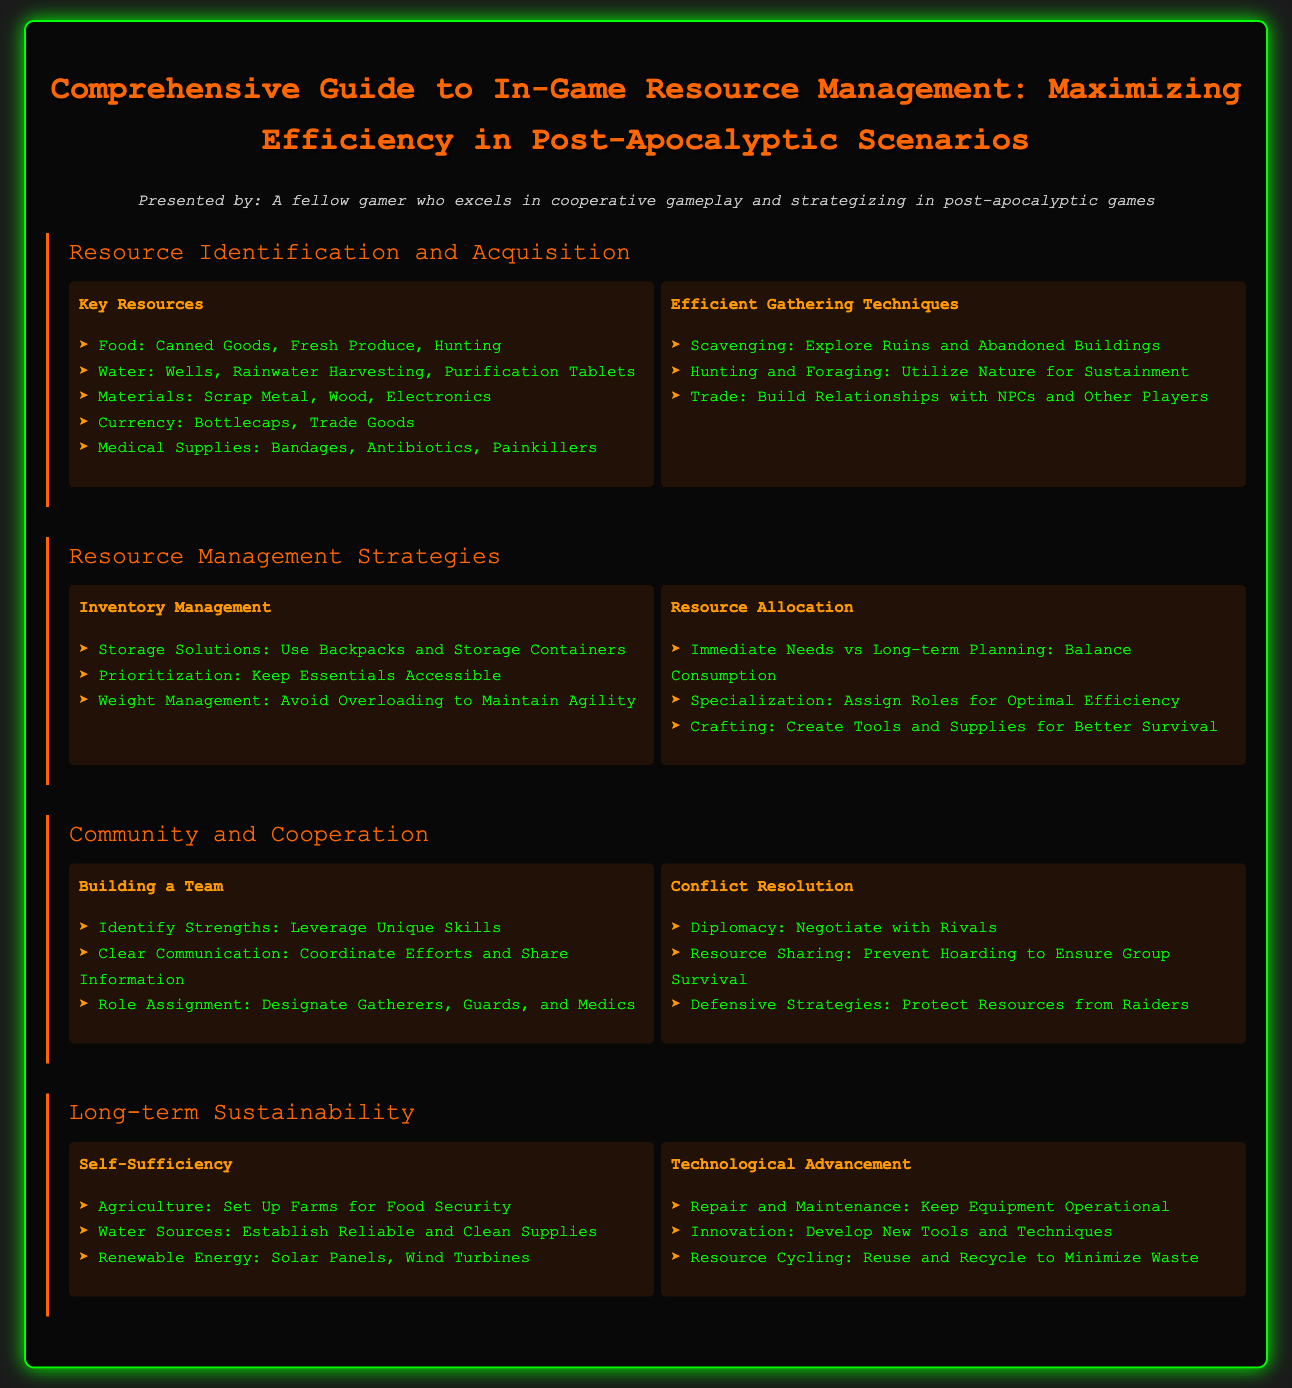what are the key medical supplies listed? The document lists medical supplies that include Bandages, Antibiotics, and Painkillers as key items.
Answer: Bandages, Antibiotics, Painkillers what are three efficient gathering techniques mentioned? The document specifies three techniques: Scavenging, Hunting and Foraging, and Trade as efficient gathering methods.
Answer: Scavenging, Hunting and Foraging, Trade what is a strategy for inventory management? The document suggests using Storage Solutions, keeping Essentials Accessible, and avoiding Overloading as strategies for inventory management.
Answer: Use Backpacks and Storage Containers name one skill needed for building a team. The document indicates that identifying strengths is key for building a team effectively.
Answer: Identify Strengths what is emphasized for long-term sustainability? The document underlines the importance of establishing self-sufficiency through agriculture and reliable water sources for long-term sustainability.
Answer: Agriculture, Water Sources how can technological advancement contribute to resource management? The document suggests Repair and Maintenance, Innovation, and Resource Cycling contribute to better resource management through technological advancement.
Answer: Repair and Maintenance what role should be assigned in a team? The document mentions that roles such as Gatherers, Guards, and Medics should be designated within the team.
Answer: Gatherers, Guards, Medics what is an immediate resource conflict resolution strategy? The document states that Diplomacy is an immediate strategy for resolving conflicts over resources.
Answer: Diplomacy 